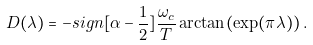Convert formula to latex. <formula><loc_0><loc_0><loc_500><loc_500>D ( \lambda ) = - s i g n [ \alpha - \frac { 1 } { 2 } ] \frac { \omega _ { c } } { T } \arctan ( \exp ( \pi \lambda ) ) \, .</formula> 